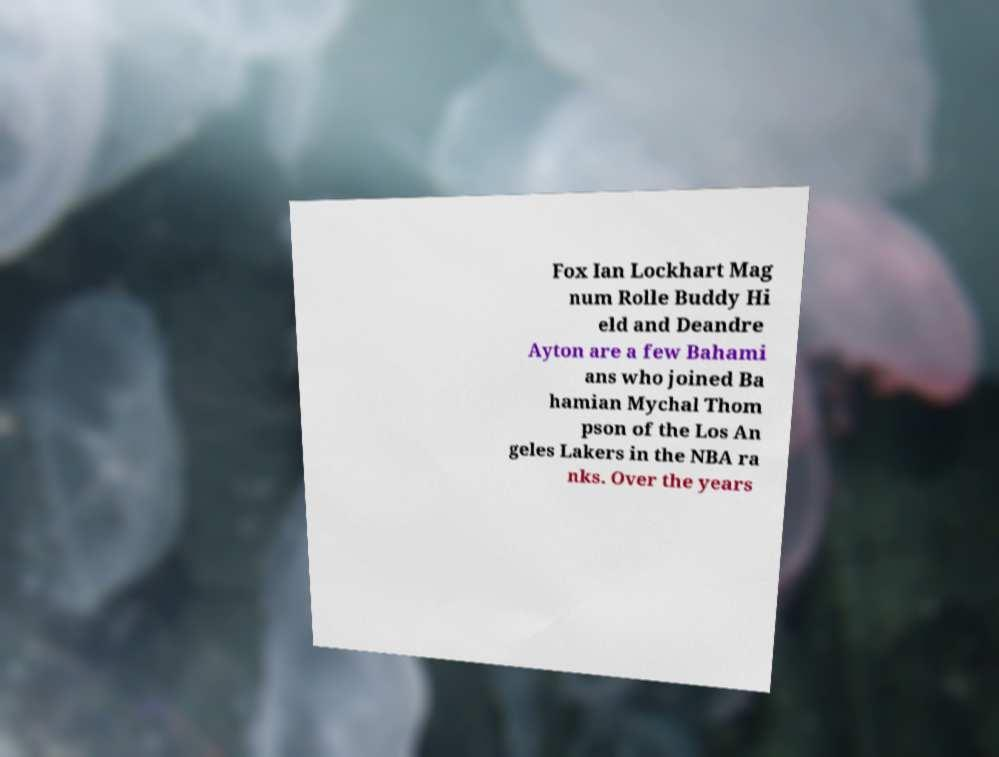I need the written content from this picture converted into text. Can you do that? Fox Ian Lockhart Mag num Rolle Buddy Hi eld and Deandre Ayton are a few Bahami ans who joined Ba hamian Mychal Thom pson of the Los An geles Lakers in the NBA ra nks. Over the years 